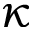Convert formula to latex. <formula><loc_0><loc_0><loc_500><loc_500>\kappa</formula> 